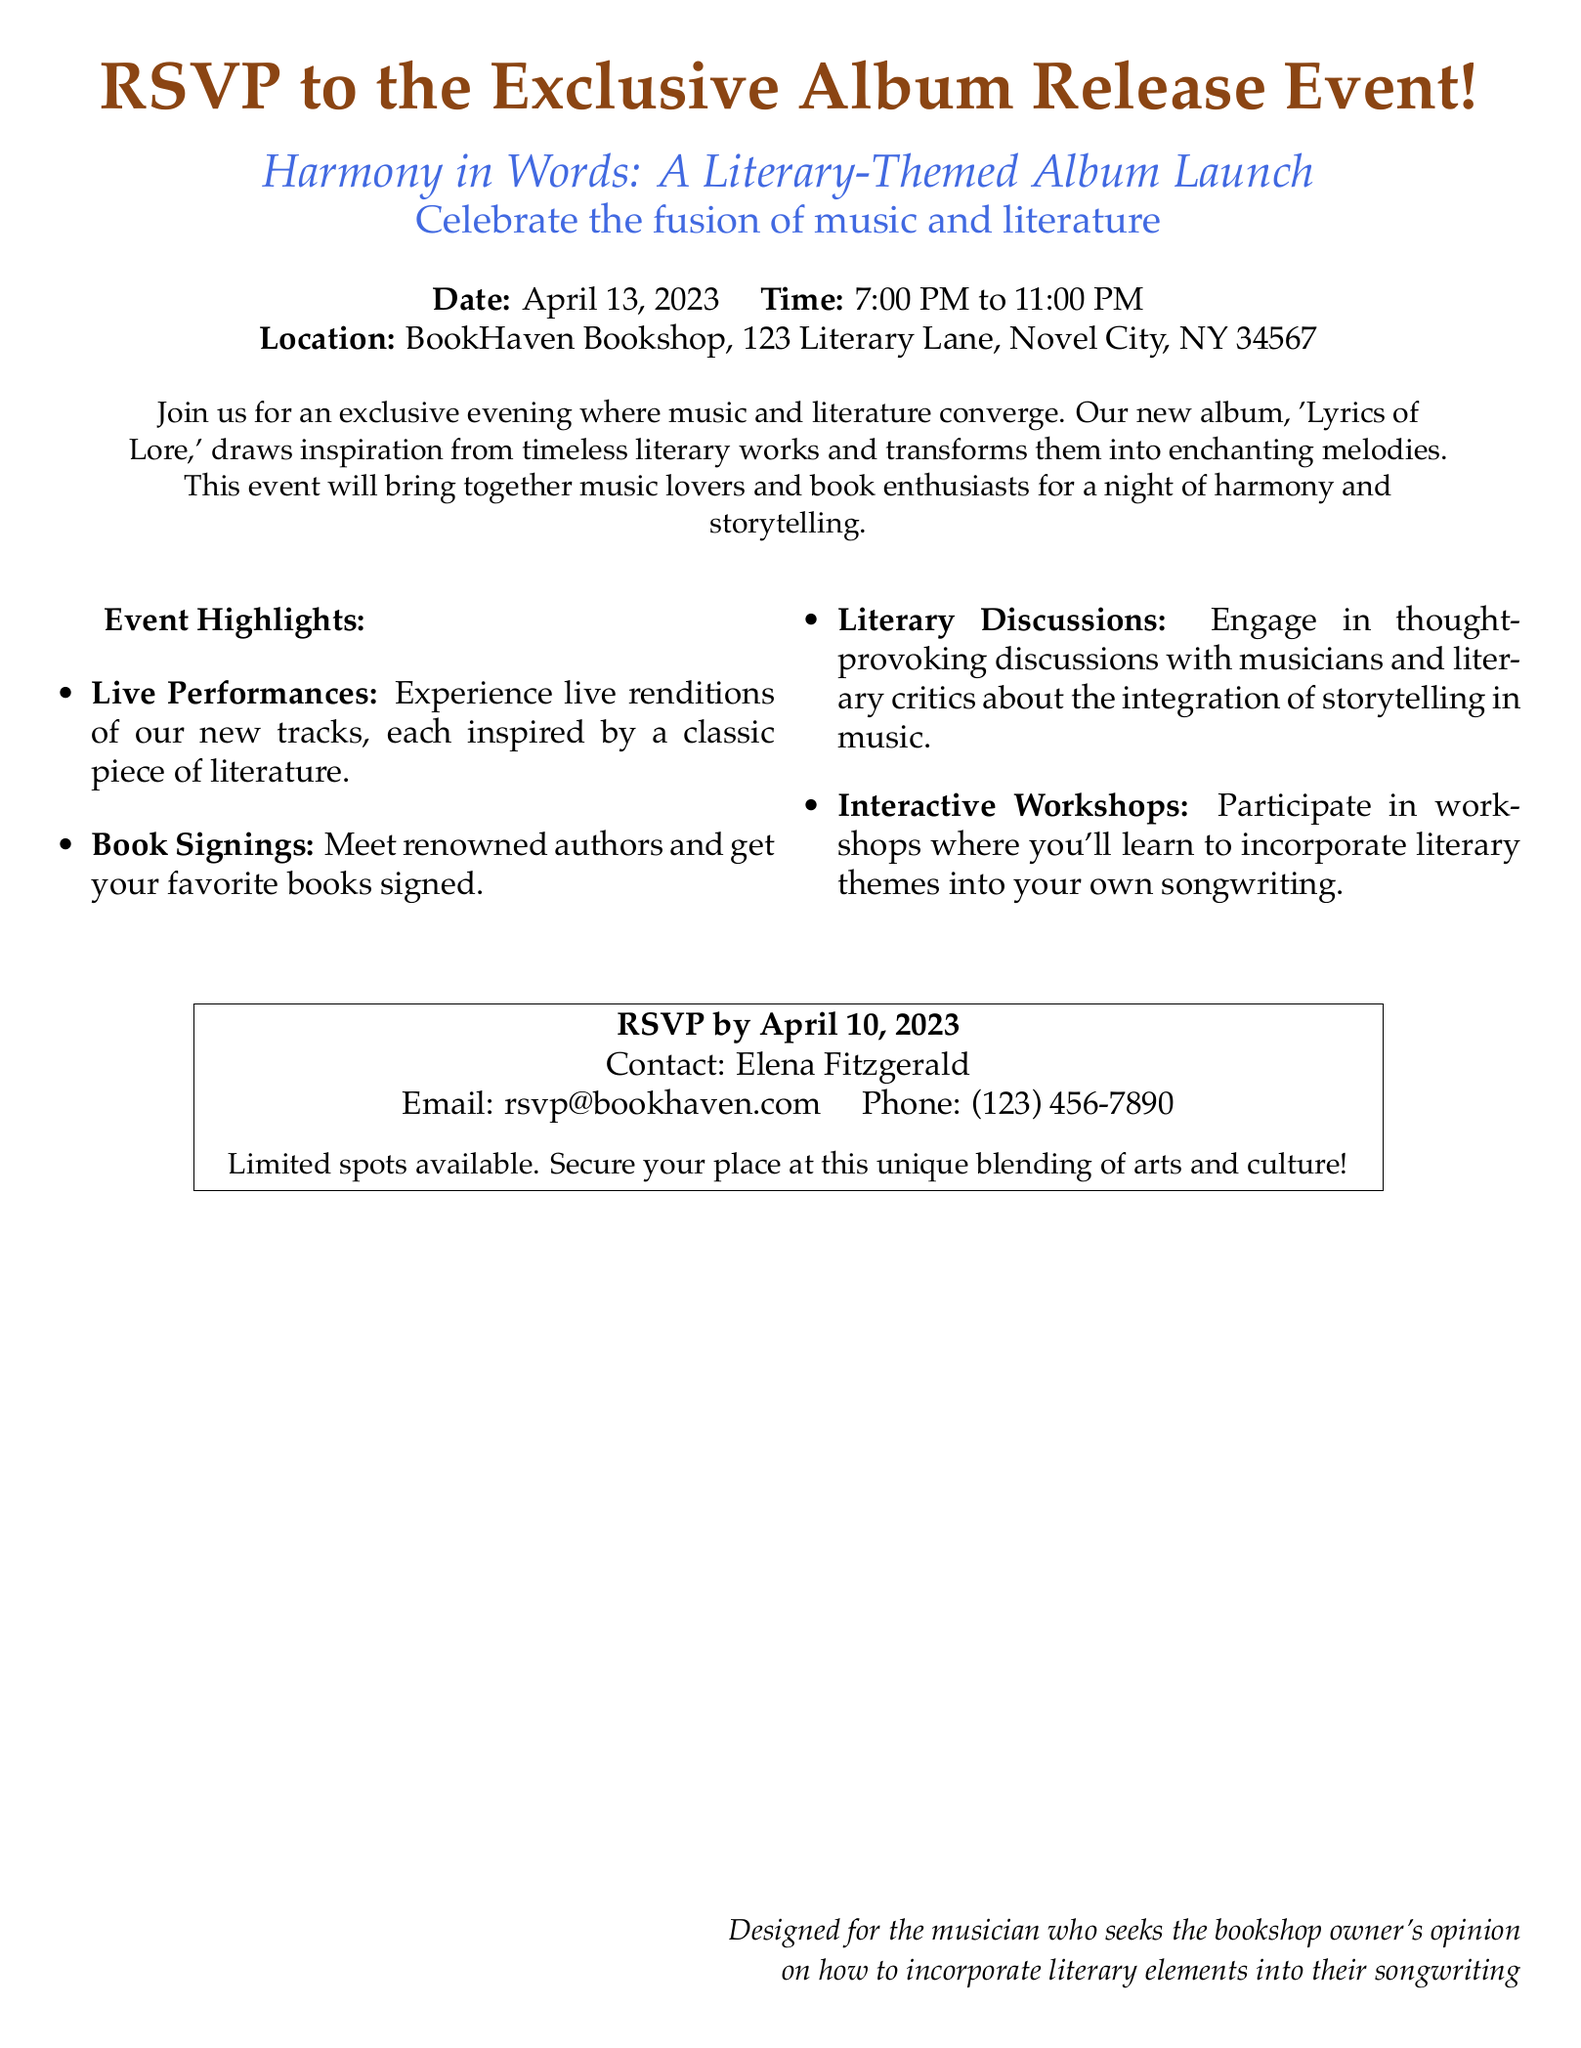what is the title of the album being launched? The title of the album is mentioned in the document as 'Lyrics of Lore.'
Answer: 'Lyrics of Lore' who is the contact person for RSVP? The document specifies that the contact person for RSVP is Elena Fitzgerald.
Answer: Elena Fitzgerald what date is the event taking place? The document clearly states the date of the event is April 13, 2023.
Answer: April 13, 2023 how long will the event last? The document indicates that the event is from 7:00 PM to 11:00 PM, totaling four hours.
Answer: 4 hours what type of performances will be featured? The document mentions live renditions of new tracks inspired by classic literature.
Answer: Live performances what can attendees participate in during the event? The document lists interactive workshops where attendees can learn about incorporating literary themes into songwriting.
Answer: Workshops how many days do attendees have to RSVP? The RSVP deadline is specified as April 10, 2023, giving attendees three days to respond.
Answer: 3 days is there a limit on available spots? The document includes a note mentioning limited spots available for the event.
Answer: Yes what is the theme of this album launch event? The document presents the theme as the fusion of music and literature.
Answer: Harmony in Words 